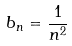<formula> <loc_0><loc_0><loc_500><loc_500>b _ { n } = \frac { 1 } { n ^ { 2 } }</formula> 